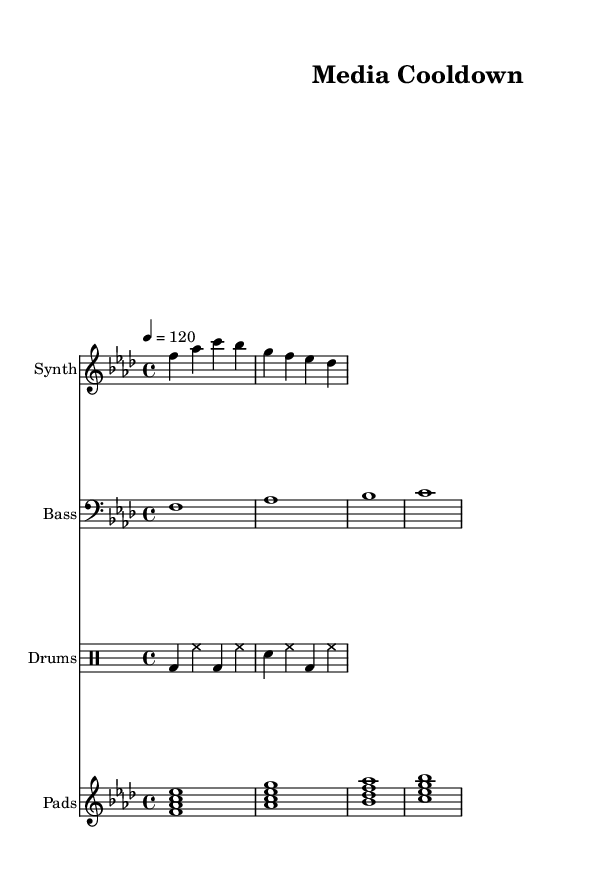What is the key signature of this music? The key signature shown at the beginning indicates F minor, which includes four flats: B flat, E flat, A flat, and D flat.
Answer: F minor What is the time signature of this music? The time signature is located near the beginning and is 4/4, indicating that there are four beats in each measure and the quarter note gets one beat.
Answer: 4/4 What is the tempo marking of the piece? The tempo marking states "4 = 120," meaning the quarter note should be played at 120 beats per minute.
Answer: 120 How many measures are in the synth music? By counting the bars in the synth music section, we find that there are two measures present in the staff.
Answer: 2 What is the instrument designated for the bass music? The bass music is labeled with a clef, indicating it will be played in a lower range, specifically the bass clef.
Answer: Bass How many unique chords are played in the pads music? Analyzing the pads music, we can identify four unique chords played over the measures, which are F, A flat, B flat, and C.
Answer: 4 What type of music is represented here? The title of the score, "Media Cooldown," and the use of electronic elements and tempo indicate that it is a type of dance music, specifically deep house.
Answer: Dance 